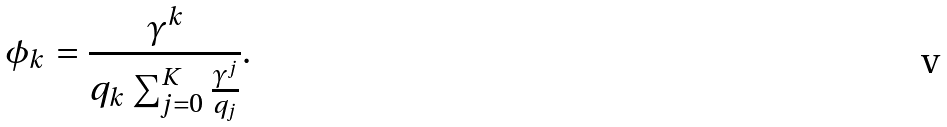Convert formula to latex. <formula><loc_0><loc_0><loc_500><loc_500>\phi _ { k } = \frac { \gamma ^ { k } } { q _ { k } \sum _ { j = 0 } ^ { K } \frac { \gamma ^ { j } } { q _ { j } } } .</formula> 